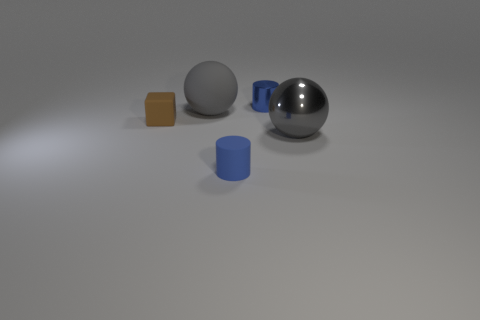Subtract all gray balls. How many were subtracted if there are1gray balls left? 1 Add 2 purple cylinders. How many objects exist? 7 Subtract all spheres. How many objects are left? 3 Subtract 0 green balls. How many objects are left? 5 Subtract all tiny shiny cylinders. Subtract all brown matte cubes. How many objects are left? 3 Add 4 metal balls. How many metal balls are left? 5 Add 1 gray objects. How many gray objects exist? 3 